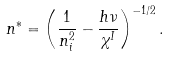<formula> <loc_0><loc_0><loc_500><loc_500>n ^ { \ast } = \left ( \frac { 1 } { n _ { i } ^ { 2 } } - \frac { h \nu } { \chi ^ { I } } \right ) ^ { - 1 / 2 } .</formula> 